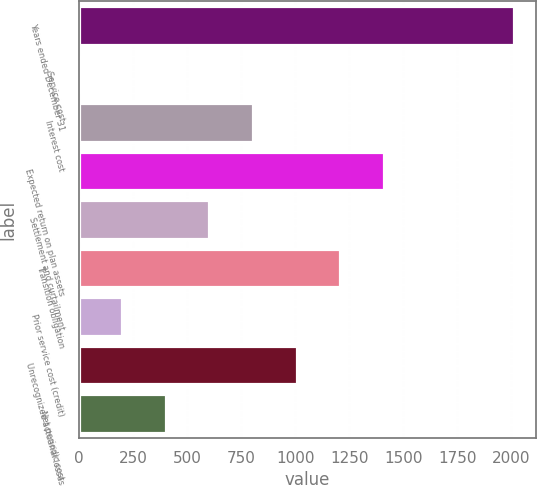Convert chart to OTSL. <chart><loc_0><loc_0><loc_500><loc_500><bar_chart><fcel>Years ended December 31<fcel>Service cost<fcel>Interest cost<fcel>Expected return on plan assets<fcel>Settlement and curtailment<fcel>Transition obligation<fcel>Prior service cost (credit)<fcel>Unrecognized actuarial losses<fcel>Net periodic cost<nl><fcel>2014<fcel>0.1<fcel>805.66<fcel>1409.83<fcel>604.27<fcel>1208.44<fcel>201.49<fcel>1007.05<fcel>402.88<nl></chart> 